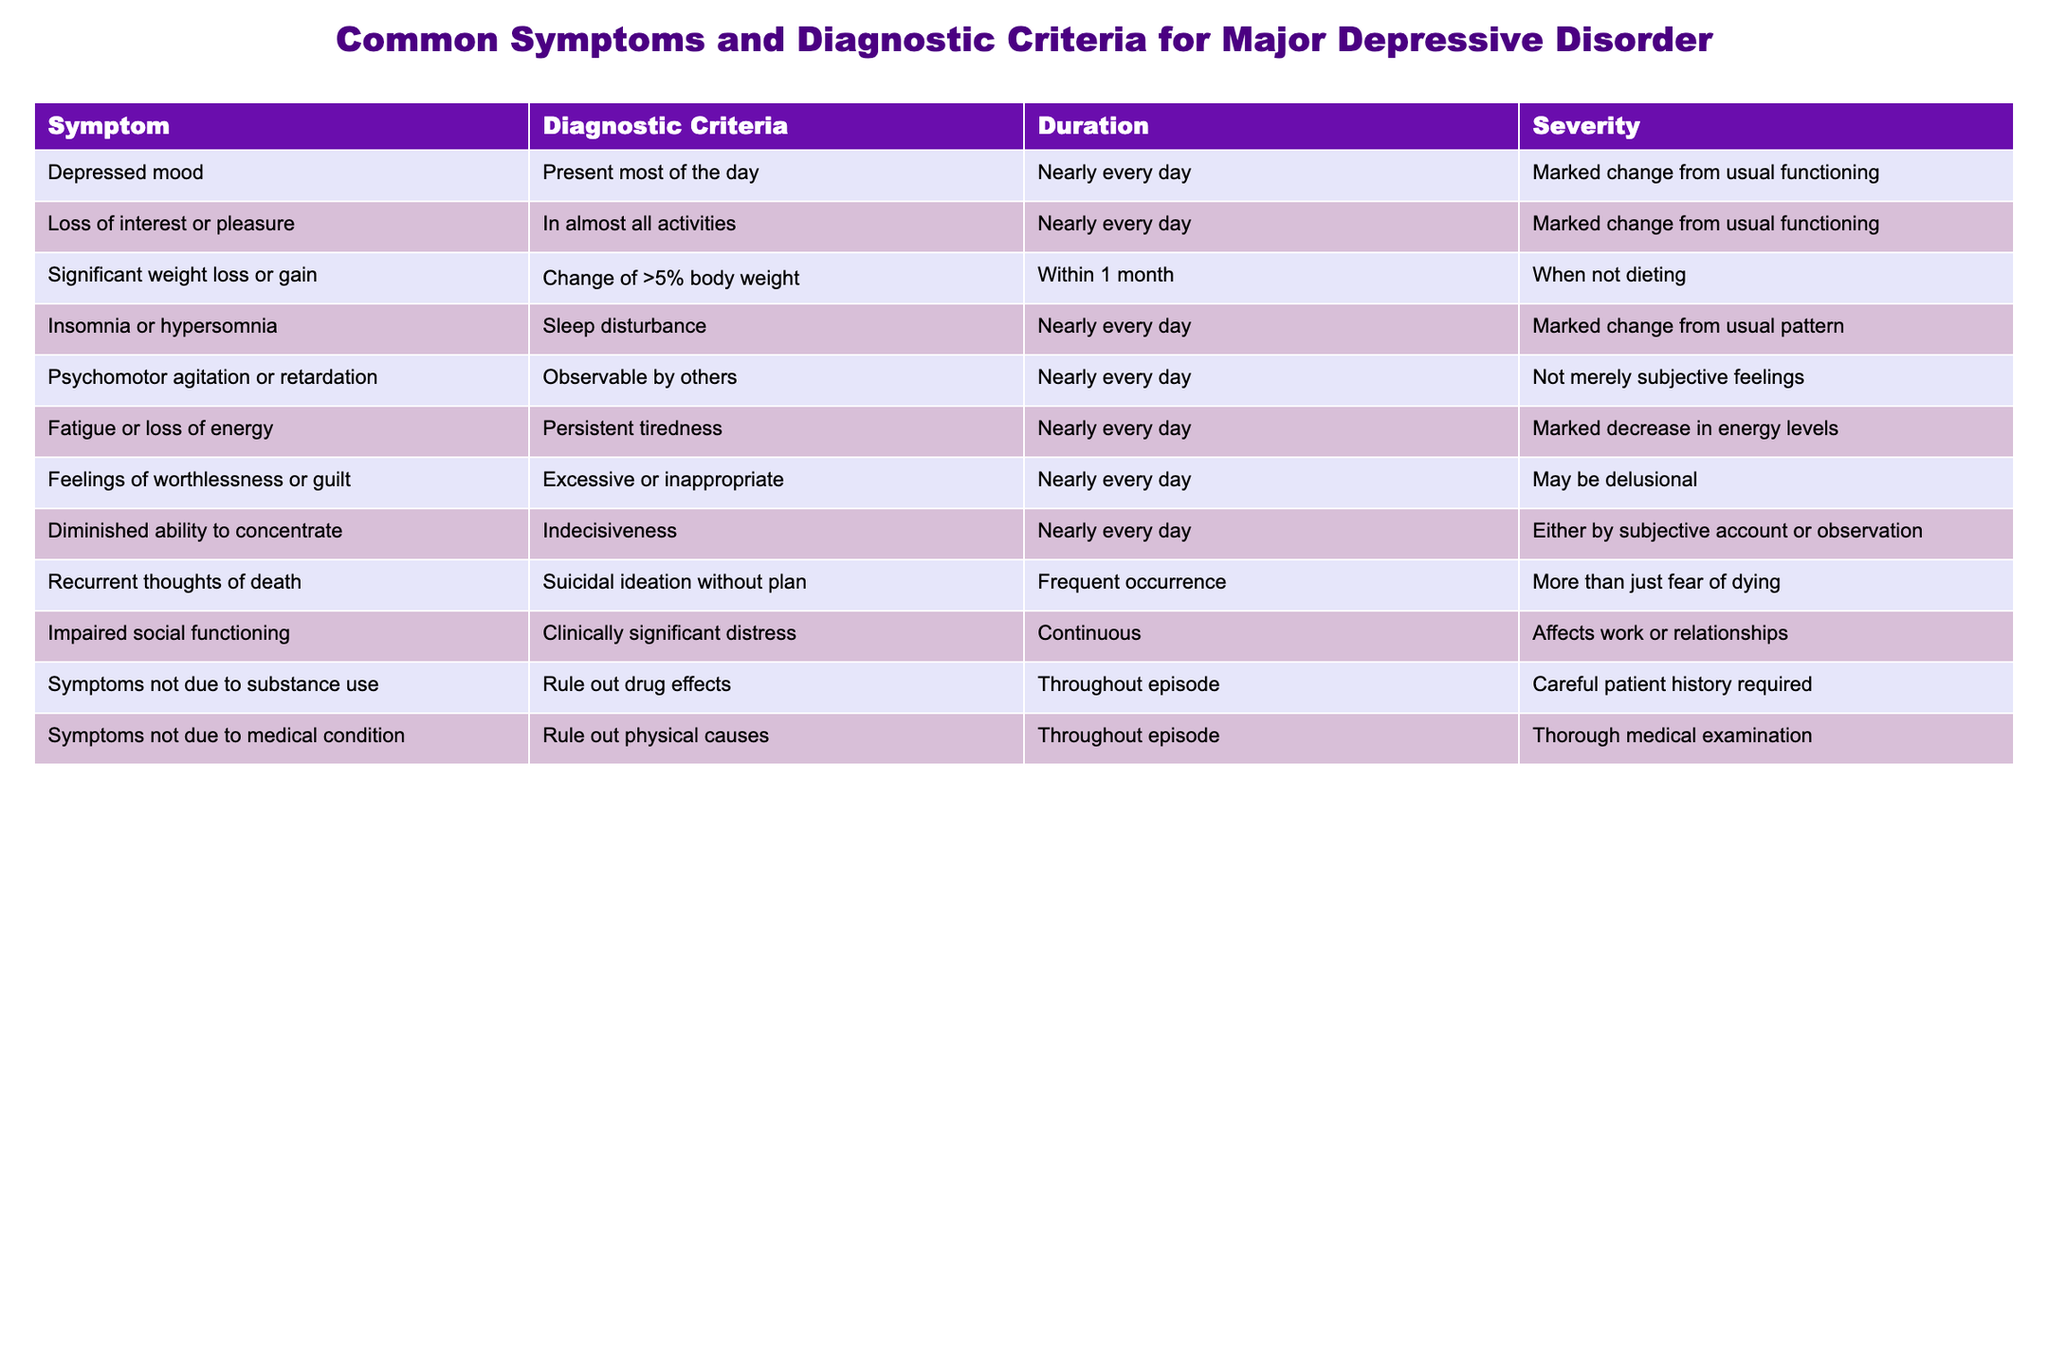What is the symptom related to feelings of worthlessness or guilt? The table indicates the symptom associated with feelings of worthlessness or guilt is described as "Excessive or inappropriate"
Answer: Excessive or inappropriate How long do symptoms of insomnia or hypersomnia need to be present for a diagnosis? The table shows that symptoms of insomnia or hypersomnia must be present "Nearly every day" to meet the diagnostic criteria
Answer: Nearly every day What is the severity of diminished ability to concentrate? According to the table, diminished ability to concentrate is characterized as either by subjective account or observation
Answer: Either by subjective account or observation Is significant weight loss or gain included in the diagnostic criteria? Yes, the table confirms that significant weight loss or gain is part of the diagnostic criteria
Answer: Yes How many symptoms need to be present for a diagnosis of major depressive disorder? The table doesn't explicitly state a number, but major depressive disorder typically requires the presence of five or more symptoms
Answer: Not stated in table Which symptom has a requirement of a careful patient history? The symptom related to substance use states "Rule out drug effects," which implies requiring careful patient history
Answer: Symptoms not due to substance use If someone experiences suicidal ideation without a plan, what is this classified as? This is classified under "Recurrent thoughts of death" according to the table
Answer: Recurrent thoughts of death Do all symptoms need to be present continuously for a diagnosis? No, the table indicates that while some symptoms like impaired social functioning need to be continuous, others can appear less frequently
Answer: No What is the time frame for assessing weight change in the context of significant weight loss or gain? The table specifies that the time frame for assessing weight change is "Within 1 month" and involves a change of more than 5% body weight
Answer: Within 1 month What are the specific examples of sleep disturbances mentioned in the table? The table specifies either insomnia or hypersomnia as sleep disturbances
Answer: Insomnia or hypersomnia What is the definition of psychomotor agitation or retardation according to the table? The table defines psychomotor agitation or retardation as being "Observable by others"
Answer: Observable by others 